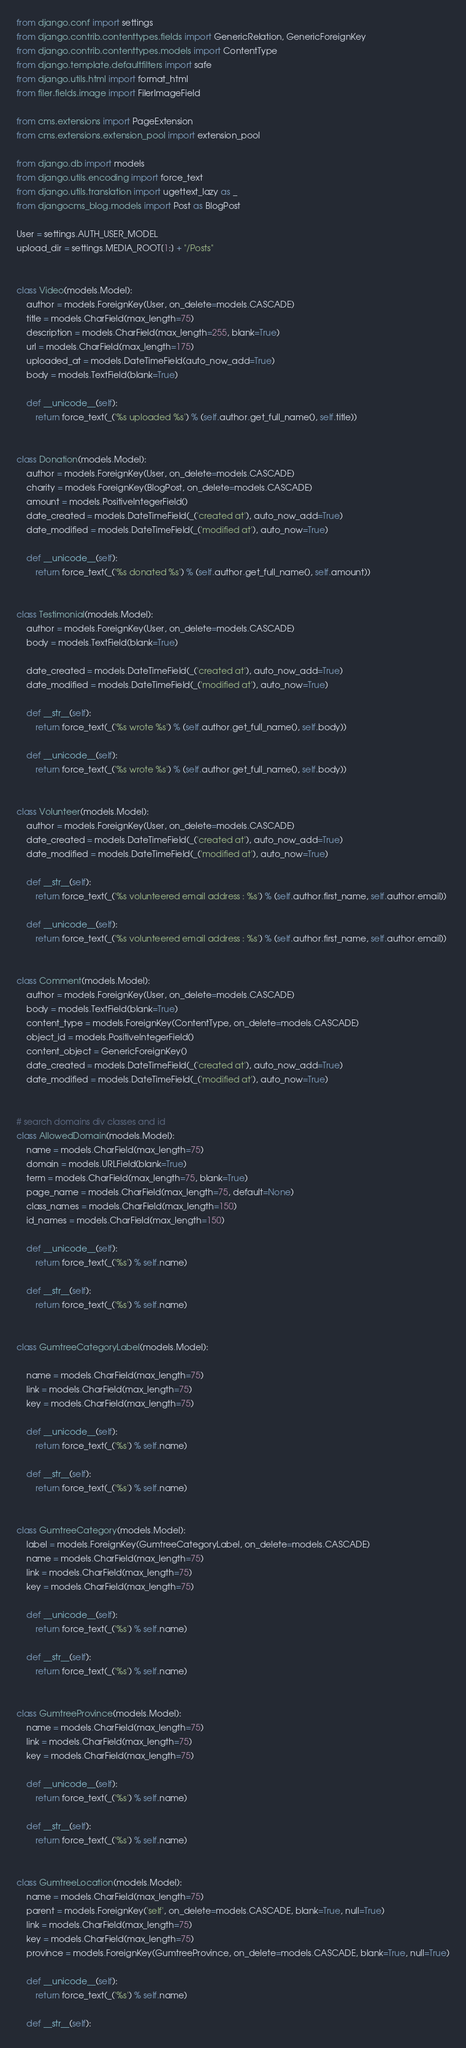Convert code to text. <code><loc_0><loc_0><loc_500><loc_500><_Python_>from django.conf import settings
from django.contrib.contenttypes.fields import GenericRelation, GenericForeignKey
from django.contrib.contenttypes.models import ContentType
from django.template.defaultfilters import safe
from django.utils.html import format_html
from filer.fields.image import FilerImageField

from cms.extensions import PageExtension
from cms.extensions.extension_pool import extension_pool

from django.db import models
from django.utils.encoding import force_text
from django.utils.translation import ugettext_lazy as _
from djangocms_blog.models import Post as BlogPost

User = settings.AUTH_USER_MODEL
upload_dir = settings.MEDIA_ROOT[1:] + "/Posts"


class Video(models.Model):
    author = models.ForeignKey(User, on_delete=models.CASCADE)
    title = models.CharField(max_length=75)
    description = models.CharField(max_length=255, blank=True)
    url = models.CharField(max_length=175)
    uploaded_at = models.DateTimeField(auto_now_add=True)
    body = models.TextField(blank=True)

    def __unicode__(self):
        return force_text(_('%s uploaded %s') % (self.author.get_full_name(), self.title))


class Donation(models.Model):
    author = models.ForeignKey(User, on_delete=models.CASCADE)
    charity = models.ForeignKey(BlogPost, on_delete=models.CASCADE)
    amount = models.PositiveIntegerField()
    date_created = models.DateTimeField(_('created at'), auto_now_add=True)
    date_modified = models.DateTimeField(_('modified at'), auto_now=True)

    def __unicode__(self):
        return force_text(_('%s donated %s') % (self.author.get_full_name(), self.amount))


class Testimonial(models.Model):
    author = models.ForeignKey(User, on_delete=models.CASCADE)
    body = models.TextField(blank=True)

    date_created = models.DateTimeField(_('created at'), auto_now_add=True)
    date_modified = models.DateTimeField(_('modified at'), auto_now=True)

    def __str__(self):
        return force_text(_('%s wrote %s') % (self.author.get_full_name(), self.body))

    def __unicode__(self):
        return force_text(_('%s wrote %s') % (self.author.get_full_name(), self.body))


class Volunteer(models.Model):
    author = models.ForeignKey(User, on_delete=models.CASCADE)
    date_created = models.DateTimeField(_('created at'), auto_now_add=True)
    date_modified = models.DateTimeField(_('modified at'), auto_now=True)

    def __str__(self):
        return force_text(_('%s volunteered email address : %s') % (self.author.first_name, self.author.email))

    def __unicode__(self):
        return force_text(_('%s volunteered email address : %s') % (self.author.first_name, self.author.email))


class Comment(models.Model):
    author = models.ForeignKey(User, on_delete=models.CASCADE)
    body = models.TextField(blank=True)
    content_type = models.ForeignKey(ContentType, on_delete=models.CASCADE)
    object_id = models.PositiveIntegerField()
    content_object = GenericForeignKey()
    date_created = models.DateTimeField(_('created at'), auto_now_add=True)
    date_modified = models.DateTimeField(_('modified at'), auto_now=True)


# search domains div classes and id
class AllowedDomain(models.Model):
    name = models.CharField(max_length=75)
    domain = models.URLField(blank=True)
    term = models.CharField(max_length=75, blank=True)
    page_name = models.CharField(max_length=75, default=None)
    class_names = models.CharField(max_length=150)
    id_names = models.CharField(max_length=150)

    def __unicode__(self):
        return force_text(_('%s') % self.name)

    def __str__(self):
        return force_text(_('%s') % self.name)


class GumtreeCategoryLabel(models.Model):

    name = models.CharField(max_length=75)
    link = models.CharField(max_length=75)
    key = models.CharField(max_length=75)

    def __unicode__(self):
        return force_text(_('%s') % self.name)

    def __str__(self):
        return force_text(_('%s') % self.name)


class GumtreeCategory(models.Model):
    label = models.ForeignKey(GumtreeCategoryLabel, on_delete=models.CASCADE)
    name = models.CharField(max_length=75)
    link = models.CharField(max_length=75)
    key = models.CharField(max_length=75)

    def __unicode__(self):
        return force_text(_('%s') % self.name)

    def __str__(self):
        return force_text(_('%s') % self.name)


class GumtreeProvince(models.Model):
    name = models.CharField(max_length=75)
    link = models.CharField(max_length=75)
    key = models.CharField(max_length=75)

    def __unicode__(self):
        return force_text(_('%s') % self.name)

    def __str__(self):
        return force_text(_('%s') % self.name)


class GumtreeLocation(models.Model):
    name = models.CharField(max_length=75)
    parent = models.ForeignKey('self', on_delete=models.CASCADE, blank=True, null=True)
    link = models.CharField(max_length=75)
    key = models.CharField(max_length=75)
    province = models.ForeignKey(GumtreeProvince, on_delete=models.CASCADE, blank=True, null=True)

    def __unicode__(self):
        return force_text(_('%s') % self.name)

    def __str__(self):</code> 